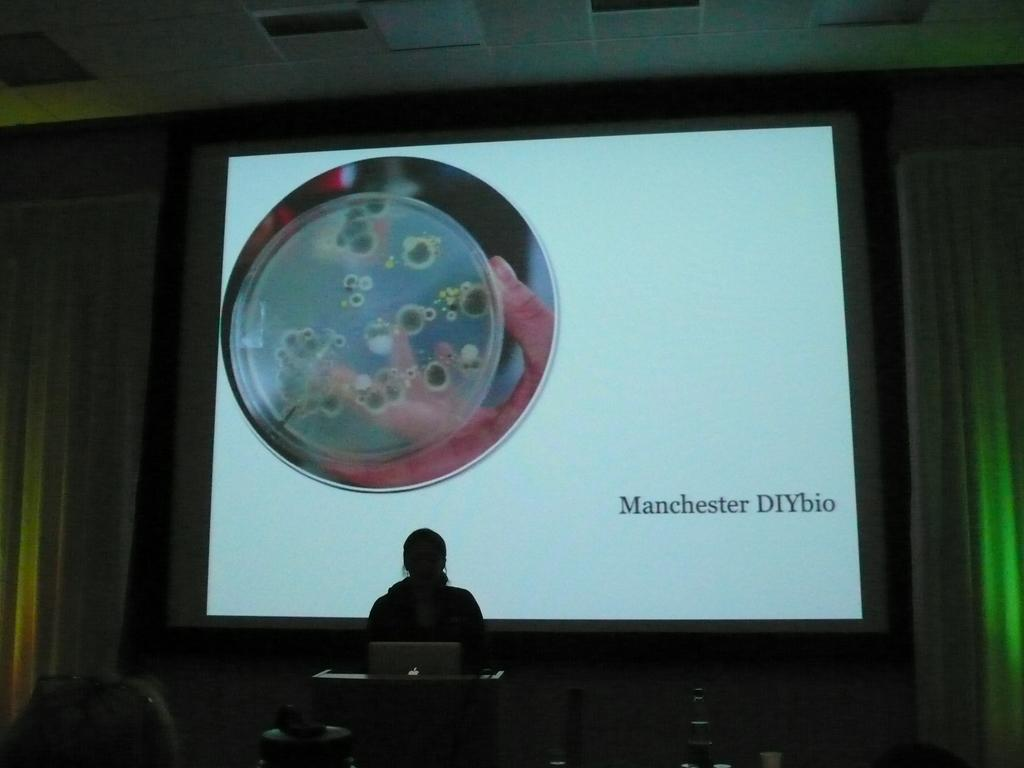Provide a one-sentence caption for the provided image. A woman is giving a speech with a slide behind her that says Machester DIYbio. 